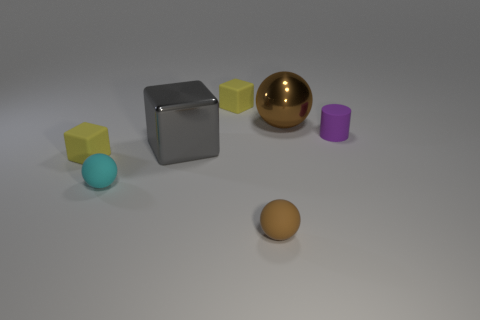The shiny ball is what color?
Give a very brief answer. Brown. What color is the tiny matte cylinder that is behind the tiny rubber sphere that is to the left of the tiny brown rubber sphere?
Your response must be concise. Purple. Is there a tiny cyan sphere made of the same material as the big cube?
Offer a very short reply. No. What material is the brown thing on the right side of the sphere in front of the cyan rubber ball?
Give a very brief answer. Metal. How many yellow objects have the same shape as the small brown matte object?
Make the answer very short. 0. What is the shape of the purple rubber thing?
Offer a terse response. Cylinder. Is the number of shiny things less than the number of cubes?
Offer a terse response. Yes. Is there any other thing that has the same size as the matte cylinder?
Your answer should be very brief. Yes. What material is the tiny brown object that is the same shape as the tiny cyan rubber thing?
Your response must be concise. Rubber. Are there more things than large shiny spheres?
Your answer should be compact. Yes. 